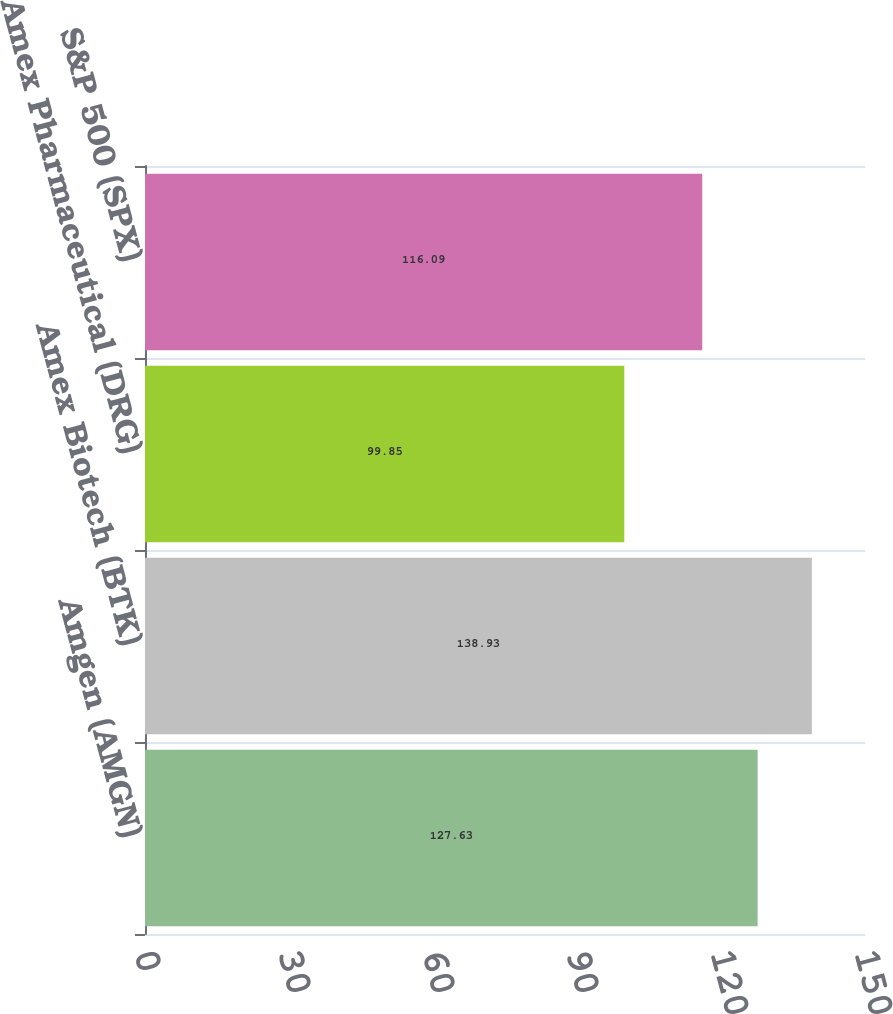Convert chart to OTSL. <chart><loc_0><loc_0><loc_500><loc_500><bar_chart><fcel>Amgen (AMGN)<fcel>Amex Biotech (BTK)<fcel>Amex Pharmaceutical (DRG)<fcel>S&P 500 (SPX)<nl><fcel>127.63<fcel>138.93<fcel>99.85<fcel>116.09<nl></chart> 